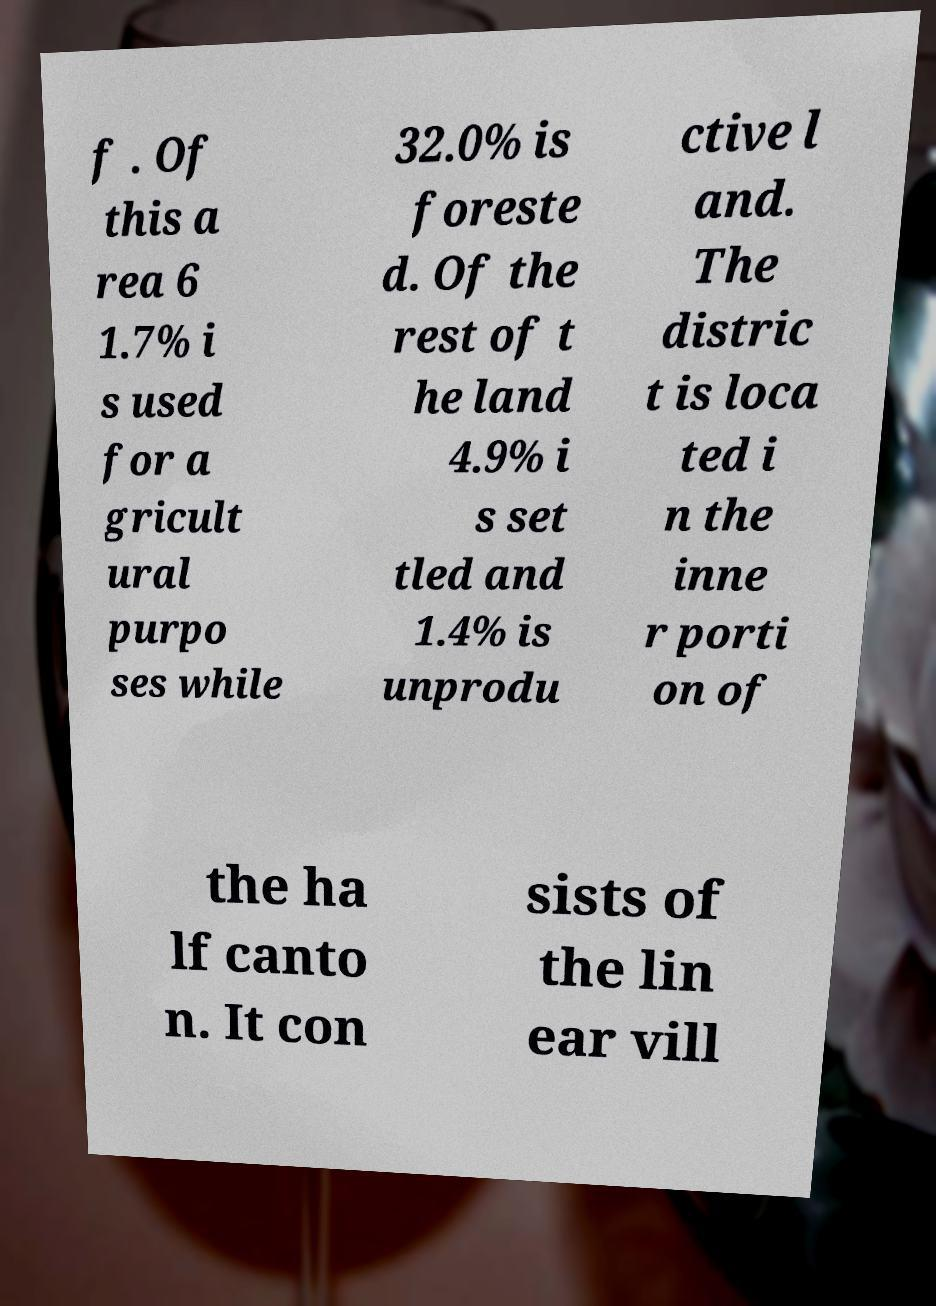Please identify and transcribe the text found in this image. f . Of this a rea 6 1.7% i s used for a gricult ural purpo ses while 32.0% is foreste d. Of the rest of t he land 4.9% i s set tled and 1.4% is unprodu ctive l and. The distric t is loca ted i n the inne r porti on of the ha lf canto n. It con sists of the lin ear vill 